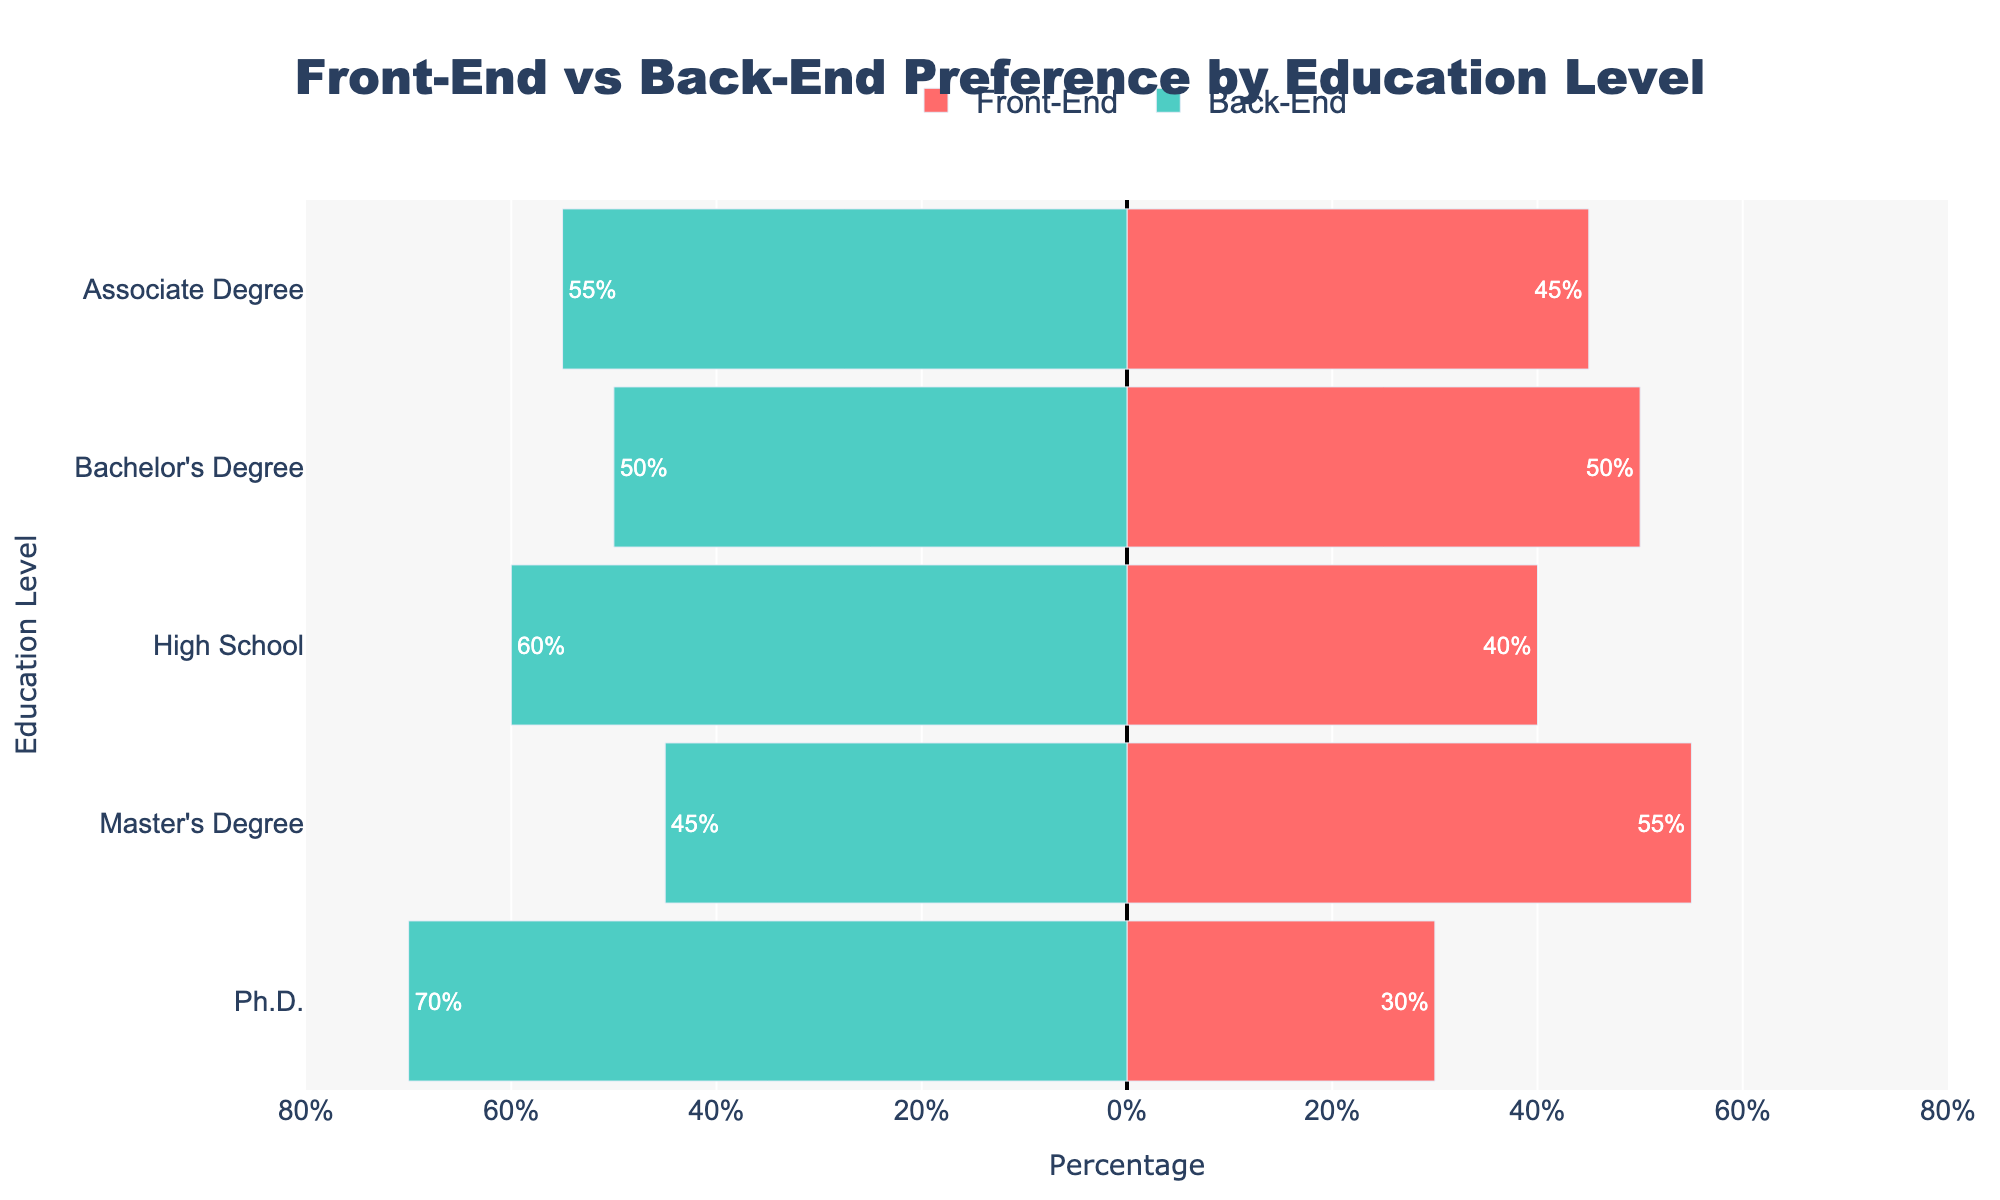What percentage of Bachelor's Degree holders prefer front-end work? Look at the bar corresponding to Bachelor's Degree for the front-end preference. The bar label shows 50%.
Answer: 50% Which education level has the highest percentage preference for back-end work? Compare all the bars for back-end preferences. The Ph.D. education level has the longest bar for back-end preference at 70%.
Answer: Ph.D Is there an education level where preferences for front-end and back-end work are equal? Look for bars where the front-end and back-end percentages are the same length. Bachelor's Degree shows both preferences at 50%.
Answer: Bachelor's Degree How does the front-end preference for Master’s Degree holders compare to Associate Degree holders? Find the front-end bar for both Master's Degree and Associate Degree. The Master's Degree is at 55%, and the Associate Degree is at 45%.
Answer: Master's Degree has 10% more than Associate Degree Which education level has the most balanced preference between front-end and back-end work? Compare the differences between front-end and back-end percentages for each education level. Bachelor's Degree shows an equal distribution of 50% for both.
Answer: Bachelor's Degree What is the combined percentage of front-end work preference for those with a High School or lower education? Sum up the front-end preferences for High School: 40%.
Answer: 40% Compare the preference for back-end work between High School and Master's Degree. Look at the back-end bars for High School and Master's Degree. High School is at 60%, and Master's Degree is at 45%.
Answer: High School has 15% more than Master’s Degree Which preference is more favored among Ph.D. holders? Look at the bars for Ph.D. for both front-end and back-end. Front-end is 30%, and back-end is 70%.
Answer: Back-End Calculate the overall average preference for back-end work across all education levels. Sum up the back-end percentages (60, 55, 50, 45, 70) and divide by the number of levels (5): (60 + 55 + 50 + 45 + 70) / 5 = 56%.
Answer: 56% 